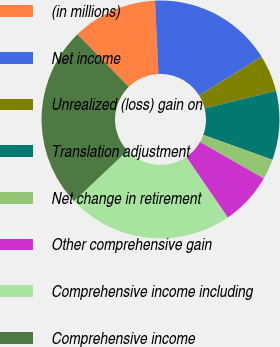Convert chart. <chart><loc_0><loc_0><loc_500><loc_500><pie_chart><fcel>(in millions)<fcel>Net income<fcel>Unrealized (loss) gain on<fcel>Translation adjustment<fcel>Net change in retirement<fcel>Other comprehensive gain<fcel>Comprehensive income including<fcel>Comprehensive income<nl><fcel>11.57%<fcel>16.9%<fcel>4.97%<fcel>9.37%<fcel>2.76%<fcel>7.17%<fcel>22.53%<fcel>24.73%<nl></chart> 